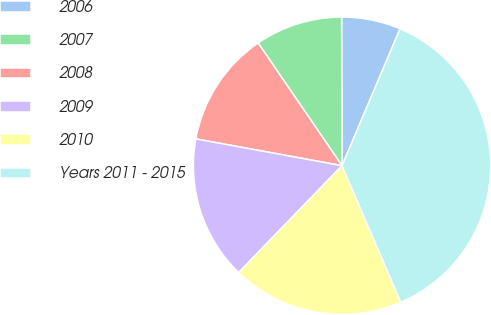Convert chart to OTSL. <chart><loc_0><loc_0><loc_500><loc_500><pie_chart><fcel>2006<fcel>2007<fcel>2008<fcel>2009<fcel>2010<fcel>Years 2011 - 2015<nl><fcel>6.43%<fcel>9.5%<fcel>12.57%<fcel>15.64%<fcel>18.71%<fcel>37.14%<nl></chart> 